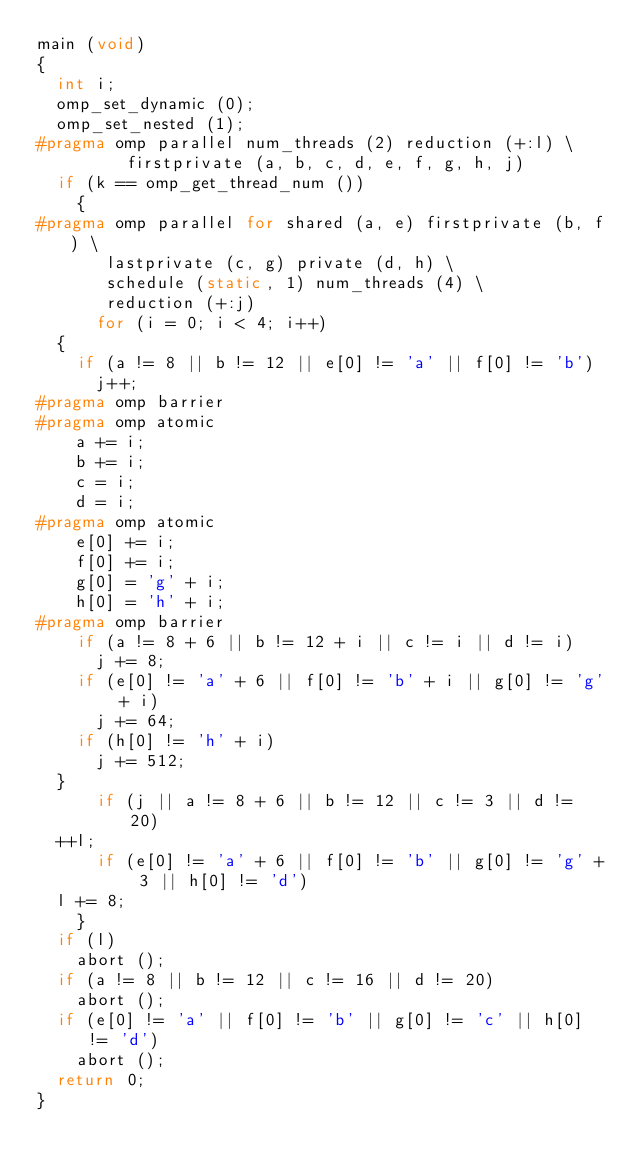<code> <loc_0><loc_0><loc_500><loc_500><_C_>main (void)
{
  int i;
  omp_set_dynamic (0);
  omp_set_nested (1);
#pragma omp parallel num_threads (2) reduction (+:l) \
		     firstprivate (a, b, c, d, e, f, g, h, j)
  if (k == omp_get_thread_num ())
    {
#pragma omp parallel for shared (a, e) firstprivate (b, f) \
			 lastprivate (c, g) private (d, h) \
			 schedule (static, 1) num_threads (4) \
			 reduction (+:j)
      for (i = 0; i < 4; i++)
	{
	  if (a != 8 || b != 12 || e[0] != 'a' || f[0] != 'b')
	    j++;
#pragma omp barrier
#pragma omp atomic
	  a += i;
	  b += i;
	  c = i;
	  d = i;
#pragma omp atomic
	  e[0] += i;
	  f[0] += i;
	  g[0] = 'g' + i;
	  h[0] = 'h' + i;
#pragma omp barrier
	  if (a != 8 + 6 || b != 12 + i || c != i || d != i)
	    j += 8;
	  if (e[0] != 'a' + 6 || f[0] != 'b' + i || g[0] != 'g' + i)
	    j += 64;
	  if (h[0] != 'h' + i)
	    j += 512;
	}
      if (j || a != 8 + 6 || b != 12 || c != 3 || d != 20)
	++l;
      if (e[0] != 'a' + 6 || f[0] != 'b' || g[0] != 'g' + 3 || h[0] != 'd')
	l += 8;
    }
  if (l)
    abort ();
  if (a != 8 || b != 12 || c != 16 || d != 20)
    abort ();
  if (e[0] != 'a' || f[0] != 'b' || g[0] != 'c' || h[0] != 'd')
    abort ();
  return 0;
}
</code> 